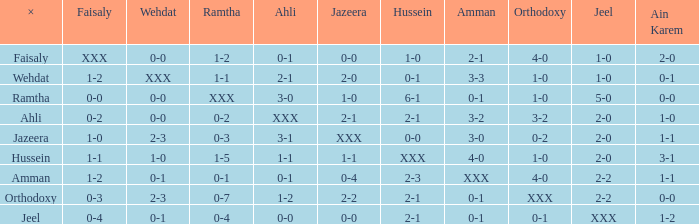When ramtha's score is 0-4, what can be said about ahli? 0-0. 